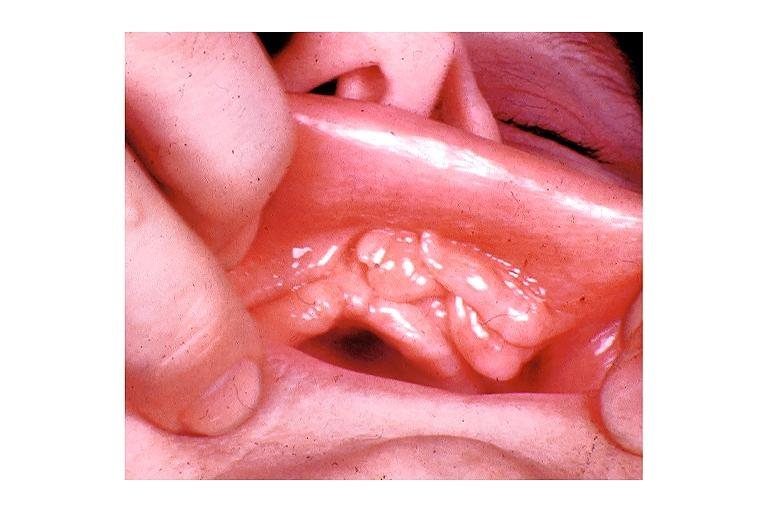where is this?
Answer the question using a single word or phrase. Oral 